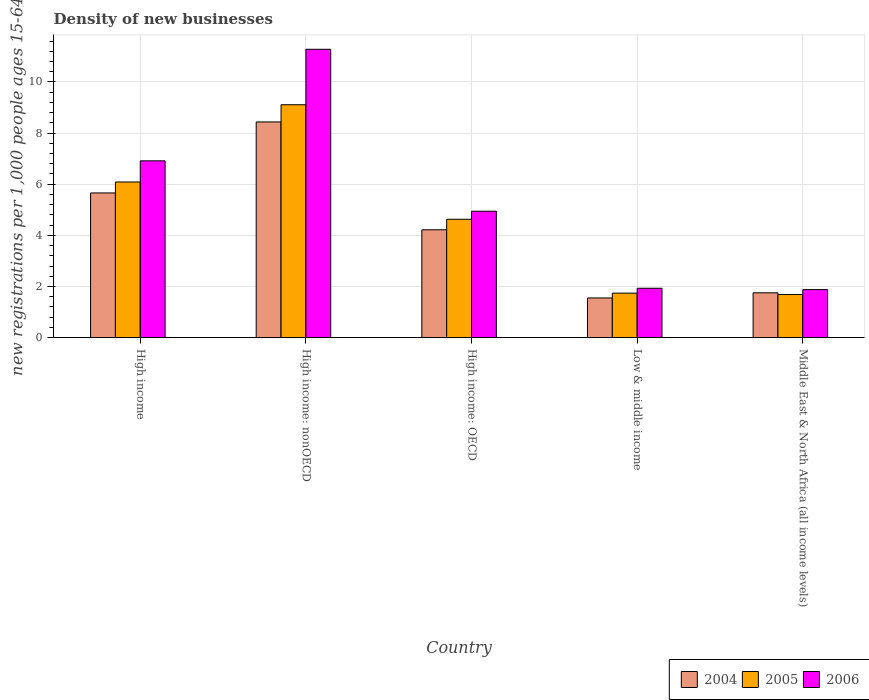How many different coloured bars are there?
Give a very brief answer. 3. Are the number of bars per tick equal to the number of legend labels?
Keep it short and to the point. Yes. What is the label of the 4th group of bars from the left?
Your answer should be very brief. Low & middle income. In how many cases, is the number of bars for a given country not equal to the number of legend labels?
Make the answer very short. 0. What is the number of new registrations in 2005 in High income?
Provide a short and direct response. 6.09. Across all countries, what is the maximum number of new registrations in 2006?
Give a very brief answer. 11.28. Across all countries, what is the minimum number of new registrations in 2005?
Your answer should be compact. 1.69. In which country was the number of new registrations in 2004 maximum?
Offer a very short reply. High income: nonOECD. In which country was the number of new registrations in 2005 minimum?
Give a very brief answer. Middle East & North Africa (all income levels). What is the total number of new registrations in 2006 in the graph?
Provide a short and direct response. 26.95. What is the difference between the number of new registrations in 2006 in High income and that in Middle East & North Africa (all income levels)?
Provide a succinct answer. 5.03. What is the difference between the number of new registrations in 2006 in High income and the number of new registrations in 2004 in High income: OECD?
Provide a succinct answer. 2.7. What is the average number of new registrations in 2004 per country?
Ensure brevity in your answer.  4.32. What is the difference between the number of new registrations of/in 2005 and number of new registrations of/in 2006 in Low & middle income?
Your answer should be compact. -0.19. In how many countries, is the number of new registrations in 2005 greater than 6.8?
Ensure brevity in your answer.  1. What is the ratio of the number of new registrations in 2005 in High income: nonOECD to that in Low & middle income?
Make the answer very short. 5.23. What is the difference between the highest and the second highest number of new registrations in 2004?
Keep it short and to the point. 4.22. What is the difference between the highest and the lowest number of new registrations in 2004?
Give a very brief answer. 6.88. In how many countries, is the number of new registrations in 2006 greater than the average number of new registrations in 2006 taken over all countries?
Provide a short and direct response. 2. Is the sum of the number of new registrations in 2006 in High income and High income: nonOECD greater than the maximum number of new registrations in 2005 across all countries?
Offer a terse response. Yes. What does the 1st bar from the left in High income: OECD represents?
Provide a succinct answer. 2004. How many bars are there?
Keep it short and to the point. 15. How many countries are there in the graph?
Ensure brevity in your answer.  5. What is the difference between two consecutive major ticks on the Y-axis?
Give a very brief answer. 2. Does the graph contain grids?
Offer a terse response. Yes. Where does the legend appear in the graph?
Provide a succinct answer. Bottom right. What is the title of the graph?
Your answer should be very brief. Density of new businesses. What is the label or title of the Y-axis?
Ensure brevity in your answer.  New registrations per 1,0 people ages 15-64. What is the new registrations per 1,000 people ages 15-64 in 2004 in High income?
Make the answer very short. 5.66. What is the new registrations per 1,000 people ages 15-64 of 2005 in High income?
Your answer should be very brief. 6.09. What is the new registrations per 1,000 people ages 15-64 of 2006 in High income?
Offer a terse response. 6.91. What is the new registrations per 1,000 people ages 15-64 of 2004 in High income: nonOECD?
Make the answer very short. 8.44. What is the new registrations per 1,000 people ages 15-64 of 2005 in High income: nonOECD?
Provide a short and direct response. 9.11. What is the new registrations per 1,000 people ages 15-64 of 2006 in High income: nonOECD?
Your response must be concise. 11.28. What is the new registrations per 1,000 people ages 15-64 in 2004 in High income: OECD?
Offer a very short reply. 4.22. What is the new registrations per 1,000 people ages 15-64 in 2005 in High income: OECD?
Offer a very short reply. 4.63. What is the new registrations per 1,000 people ages 15-64 in 2006 in High income: OECD?
Give a very brief answer. 4.94. What is the new registrations per 1,000 people ages 15-64 of 2004 in Low & middle income?
Provide a succinct answer. 1.55. What is the new registrations per 1,000 people ages 15-64 in 2005 in Low & middle income?
Offer a very short reply. 1.74. What is the new registrations per 1,000 people ages 15-64 of 2006 in Low & middle income?
Make the answer very short. 1.93. What is the new registrations per 1,000 people ages 15-64 of 2004 in Middle East & North Africa (all income levels)?
Give a very brief answer. 1.75. What is the new registrations per 1,000 people ages 15-64 of 2005 in Middle East & North Africa (all income levels)?
Provide a succinct answer. 1.69. What is the new registrations per 1,000 people ages 15-64 in 2006 in Middle East & North Africa (all income levels)?
Your answer should be very brief. 1.88. Across all countries, what is the maximum new registrations per 1,000 people ages 15-64 in 2004?
Provide a short and direct response. 8.44. Across all countries, what is the maximum new registrations per 1,000 people ages 15-64 in 2005?
Offer a very short reply. 9.11. Across all countries, what is the maximum new registrations per 1,000 people ages 15-64 in 2006?
Provide a succinct answer. 11.28. Across all countries, what is the minimum new registrations per 1,000 people ages 15-64 of 2004?
Provide a short and direct response. 1.55. Across all countries, what is the minimum new registrations per 1,000 people ages 15-64 in 2005?
Keep it short and to the point. 1.69. Across all countries, what is the minimum new registrations per 1,000 people ages 15-64 in 2006?
Offer a terse response. 1.88. What is the total new registrations per 1,000 people ages 15-64 of 2004 in the graph?
Provide a short and direct response. 21.62. What is the total new registrations per 1,000 people ages 15-64 of 2005 in the graph?
Your answer should be compact. 23.25. What is the total new registrations per 1,000 people ages 15-64 in 2006 in the graph?
Provide a succinct answer. 26.95. What is the difference between the new registrations per 1,000 people ages 15-64 of 2004 in High income and that in High income: nonOECD?
Provide a short and direct response. -2.78. What is the difference between the new registrations per 1,000 people ages 15-64 in 2005 in High income and that in High income: nonOECD?
Your answer should be very brief. -3.02. What is the difference between the new registrations per 1,000 people ages 15-64 of 2006 in High income and that in High income: nonOECD?
Provide a short and direct response. -4.36. What is the difference between the new registrations per 1,000 people ages 15-64 of 2004 in High income and that in High income: OECD?
Your response must be concise. 1.44. What is the difference between the new registrations per 1,000 people ages 15-64 in 2005 in High income and that in High income: OECD?
Your answer should be very brief. 1.46. What is the difference between the new registrations per 1,000 people ages 15-64 in 2006 in High income and that in High income: OECD?
Provide a succinct answer. 1.97. What is the difference between the new registrations per 1,000 people ages 15-64 of 2004 in High income and that in Low & middle income?
Provide a short and direct response. 4.11. What is the difference between the new registrations per 1,000 people ages 15-64 of 2005 in High income and that in Low & middle income?
Offer a terse response. 4.35. What is the difference between the new registrations per 1,000 people ages 15-64 of 2006 in High income and that in Low & middle income?
Keep it short and to the point. 4.98. What is the difference between the new registrations per 1,000 people ages 15-64 of 2004 in High income and that in Middle East & North Africa (all income levels)?
Offer a terse response. 3.91. What is the difference between the new registrations per 1,000 people ages 15-64 in 2005 in High income and that in Middle East & North Africa (all income levels)?
Ensure brevity in your answer.  4.4. What is the difference between the new registrations per 1,000 people ages 15-64 of 2006 in High income and that in Middle East & North Africa (all income levels)?
Make the answer very short. 5.04. What is the difference between the new registrations per 1,000 people ages 15-64 in 2004 in High income: nonOECD and that in High income: OECD?
Your answer should be very brief. 4.22. What is the difference between the new registrations per 1,000 people ages 15-64 in 2005 in High income: nonOECD and that in High income: OECD?
Give a very brief answer. 4.48. What is the difference between the new registrations per 1,000 people ages 15-64 in 2006 in High income: nonOECD and that in High income: OECD?
Provide a short and direct response. 6.33. What is the difference between the new registrations per 1,000 people ages 15-64 of 2004 in High income: nonOECD and that in Low & middle income?
Your answer should be very brief. 6.88. What is the difference between the new registrations per 1,000 people ages 15-64 in 2005 in High income: nonOECD and that in Low & middle income?
Ensure brevity in your answer.  7.37. What is the difference between the new registrations per 1,000 people ages 15-64 of 2006 in High income: nonOECD and that in Low & middle income?
Your response must be concise. 9.34. What is the difference between the new registrations per 1,000 people ages 15-64 in 2004 in High income: nonOECD and that in Middle East & North Africa (all income levels)?
Provide a short and direct response. 6.68. What is the difference between the new registrations per 1,000 people ages 15-64 in 2005 in High income: nonOECD and that in Middle East & North Africa (all income levels)?
Provide a short and direct response. 7.42. What is the difference between the new registrations per 1,000 people ages 15-64 in 2006 in High income: nonOECD and that in Middle East & North Africa (all income levels)?
Make the answer very short. 9.4. What is the difference between the new registrations per 1,000 people ages 15-64 of 2004 in High income: OECD and that in Low & middle income?
Provide a succinct answer. 2.67. What is the difference between the new registrations per 1,000 people ages 15-64 of 2005 in High income: OECD and that in Low & middle income?
Ensure brevity in your answer.  2.89. What is the difference between the new registrations per 1,000 people ages 15-64 in 2006 in High income: OECD and that in Low & middle income?
Keep it short and to the point. 3.01. What is the difference between the new registrations per 1,000 people ages 15-64 in 2004 in High income: OECD and that in Middle East & North Africa (all income levels)?
Keep it short and to the point. 2.47. What is the difference between the new registrations per 1,000 people ages 15-64 of 2005 in High income: OECD and that in Middle East & North Africa (all income levels)?
Give a very brief answer. 2.94. What is the difference between the new registrations per 1,000 people ages 15-64 in 2006 in High income: OECD and that in Middle East & North Africa (all income levels)?
Offer a very short reply. 3.07. What is the difference between the new registrations per 1,000 people ages 15-64 of 2004 in Low & middle income and that in Middle East & North Africa (all income levels)?
Provide a short and direct response. -0.2. What is the difference between the new registrations per 1,000 people ages 15-64 of 2005 in Low & middle income and that in Middle East & North Africa (all income levels)?
Provide a short and direct response. 0.05. What is the difference between the new registrations per 1,000 people ages 15-64 in 2006 in Low & middle income and that in Middle East & North Africa (all income levels)?
Give a very brief answer. 0.05. What is the difference between the new registrations per 1,000 people ages 15-64 of 2004 in High income and the new registrations per 1,000 people ages 15-64 of 2005 in High income: nonOECD?
Your answer should be very brief. -3.45. What is the difference between the new registrations per 1,000 people ages 15-64 of 2004 in High income and the new registrations per 1,000 people ages 15-64 of 2006 in High income: nonOECD?
Provide a short and direct response. -5.62. What is the difference between the new registrations per 1,000 people ages 15-64 in 2005 in High income and the new registrations per 1,000 people ages 15-64 in 2006 in High income: nonOECD?
Provide a succinct answer. -5.19. What is the difference between the new registrations per 1,000 people ages 15-64 in 2004 in High income and the new registrations per 1,000 people ages 15-64 in 2005 in High income: OECD?
Your answer should be very brief. 1.03. What is the difference between the new registrations per 1,000 people ages 15-64 of 2004 in High income and the new registrations per 1,000 people ages 15-64 of 2006 in High income: OECD?
Keep it short and to the point. 0.71. What is the difference between the new registrations per 1,000 people ages 15-64 of 2005 in High income and the new registrations per 1,000 people ages 15-64 of 2006 in High income: OECD?
Keep it short and to the point. 1.14. What is the difference between the new registrations per 1,000 people ages 15-64 in 2004 in High income and the new registrations per 1,000 people ages 15-64 in 2005 in Low & middle income?
Your answer should be compact. 3.92. What is the difference between the new registrations per 1,000 people ages 15-64 of 2004 in High income and the new registrations per 1,000 people ages 15-64 of 2006 in Low & middle income?
Give a very brief answer. 3.73. What is the difference between the new registrations per 1,000 people ages 15-64 in 2005 in High income and the new registrations per 1,000 people ages 15-64 in 2006 in Low & middle income?
Make the answer very short. 4.16. What is the difference between the new registrations per 1,000 people ages 15-64 in 2004 in High income and the new registrations per 1,000 people ages 15-64 in 2005 in Middle East & North Africa (all income levels)?
Make the answer very short. 3.97. What is the difference between the new registrations per 1,000 people ages 15-64 in 2004 in High income and the new registrations per 1,000 people ages 15-64 in 2006 in Middle East & North Africa (all income levels)?
Offer a terse response. 3.78. What is the difference between the new registrations per 1,000 people ages 15-64 in 2005 in High income and the new registrations per 1,000 people ages 15-64 in 2006 in Middle East & North Africa (all income levels)?
Your answer should be very brief. 4.21. What is the difference between the new registrations per 1,000 people ages 15-64 in 2004 in High income: nonOECD and the new registrations per 1,000 people ages 15-64 in 2005 in High income: OECD?
Your answer should be very brief. 3.81. What is the difference between the new registrations per 1,000 people ages 15-64 in 2004 in High income: nonOECD and the new registrations per 1,000 people ages 15-64 in 2006 in High income: OECD?
Keep it short and to the point. 3.49. What is the difference between the new registrations per 1,000 people ages 15-64 of 2005 in High income: nonOECD and the new registrations per 1,000 people ages 15-64 of 2006 in High income: OECD?
Offer a very short reply. 4.16. What is the difference between the new registrations per 1,000 people ages 15-64 of 2004 in High income: nonOECD and the new registrations per 1,000 people ages 15-64 of 2005 in Low & middle income?
Your answer should be compact. 6.69. What is the difference between the new registrations per 1,000 people ages 15-64 of 2004 in High income: nonOECD and the new registrations per 1,000 people ages 15-64 of 2006 in Low & middle income?
Offer a terse response. 6.5. What is the difference between the new registrations per 1,000 people ages 15-64 in 2005 in High income: nonOECD and the new registrations per 1,000 people ages 15-64 in 2006 in Low & middle income?
Keep it short and to the point. 7.18. What is the difference between the new registrations per 1,000 people ages 15-64 of 2004 in High income: nonOECD and the new registrations per 1,000 people ages 15-64 of 2005 in Middle East & North Africa (all income levels)?
Provide a short and direct response. 6.75. What is the difference between the new registrations per 1,000 people ages 15-64 in 2004 in High income: nonOECD and the new registrations per 1,000 people ages 15-64 in 2006 in Middle East & North Africa (all income levels)?
Your answer should be very brief. 6.56. What is the difference between the new registrations per 1,000 people ages 15-64 of 2005 in High income: nonOECD and the new registrations per 1,000 people ages 15-64 of 2006 in Middle East & North Africa (all income levels)?
Ensure brevity in your answer.  7.23. What is the difference between the new registrations per 1,000 people ages 15-64 of 2004 in High income: OECD and the new registrations per 1,000 people ages 15-64 of 2005 in Low & middle income?
Your answer should be very brief. 2.48. What is the difference between the new registrations per 1,000 people ages 15-64 of 2004 in High income: OECD and the new registrations per 1,000 people ages 15-64 of 2006 in Low & middle income?
Make the answer very short. 2.29. What is the difference between the new registrations per 1,000 people ages 15-64 of 2005 in High income: OECD and the new registrations per 1,000 people ages 15-64 of 2006 in Low & middle income?
Make the answer very short. 2.7. What is the difference between the new registrations per 1,000 people ages 15-64 in 2004 in High income: OECD and the new registrations per 1,000 people ages 15-64 in 2005 in Middle East & North Africa (all income levels)?
Keep it short and to the point. 2.53. What is the difference between the new registrations per 1,000 people ages 15-64 of 2004 in High income: OECD and the new registrations per 1,000 people ages 15-64 of 2006 in Middle East & North Africa (all income levels)?
Ensure brevity in your answer.  2.34. What is the difference between the new registrations per 1,000 people ages 15-64 of 2005 in High income: OECD and the new registrations per 1,000 people ages 15-64 of 2006 in Middle East & North Africa (all income levels)?
Provide a short and direct response. 2.75. What is the difference between the new registrations per 1,000 people ages 15-64 of 2004 in Low & middle income and the new registrations per 1,000 people ages 15-64 of 2005 in Middle East & North Africa (all income levels)?
Your response must be concise. -0.13. What is the difference between the new registrations per 1,000 people ages 15-64 in 2004 in Low & middle income and the new registrations per 1,000 people ages 15-64 in 2006 in Middle East & North Africa (all income levels)?
Your answer should be compact. -0.33. What is the difference between the new registrations per 1,000 people ages 15-64 of 2005 in Low & middle income and the new registrations per 1,000 people ages 15-64 of 2006 in Middle East & North Africa (all income levels)?
Your response must be concise. -0.14. What is the average new registrations per 1,000 people ages 15-64 in 2004 per country?
Give a very brief answer. 4.32. What is the average new registrations per 1,000 people ages 15-64 of 2005 per country?
Ensure brevity in your answer.  4.65. What is the average new registrations per 1,000 people ages 15-64 in 2006 per country?
Give a very brief answer. 5.39. What is the difference between the new registrations per 1,000 people ages 15-64 of 2004 and new registrations per 1,000 people ages 15-64 of 2005 in High income?
Provide a short and direct response. -0.43. What is the difference between the new registrations per 1,000 people ages 15-64 of 2004 and new registrations per 1,000 people ages 15-64 of 2006 in High income?
Provide a succinct answer. -1.26. What is the difference between the new registrations per 1,000 people ages 15-64 in 2005 and new registrations per 1,000 people ages 15-64 in 2006 in High income?
Give a very brief answer. -0.83. What is the difference between the new registrations per 1,000 people ages 15-64 of 2004 and new registrations per 1,000 people ages 15-64 of 2005 in High income: nonOECD?
Provide a short and direct response. -0.67. What is the difference between the new registrations per 1,000 people ages 15-64 of 2004 and new registrations per 1,000 people ages 15-64 of 2006 in High income: nonOECD?
Your answer should be compact. -2.84. What is the difference between the new registrations per 1,000 people ages 15-64 in 2005 and new registrations per 1,000 people ages 15-64 in 2006 in High income: nonOECD?
Provide a short and direct response. -2.17. What is the difference between the new registrations per 1,000 people ages 15-64 of 2004 and new registrations per 1,000 people ages 15-64 of 2005 in High income: OECD?
Your answer should be very brief. -0.41. What is the difference between the new registrations per 1,000 people ages 15-64 in 2004 and new registrations per 1,000 people ages 15-64 in 2006 in High income: OECD?
Ensure brevity in your answer.  -0.73. What is the difference between the new registrations per 1,000 people ages 15-64 in 2005 and new registrations per 1,000 people ages 15-64 in 2006 in High income: OECD?
Your answer should be compact. -0.32. What is the difference between the new registrations per 1,000 people ages 15-64 of 2004 and new registrations per 1,000 people ages 15-64 of 2005 in Low & middle income?
Give a very brief answer. -0.19. What is the difference between the new registrations per 1,000 people ages 15-64 in 2004 and new registrations per 1,000 people ages 15-64 in 2006 in Low & middle income?
Offer a terse response. -0.38. What is the difference between the new registrations per 1,000 people ages 15-64 of 2005 and new registrations per 1,000 people ages 15-64 of 2006 in Low & middle income?
Give a very brief answer. -0.19. What is the difference between the new registrations per 1,000 people ages 15-64 of 2004 and new registrations per 1,000 people ages 15-64 of 2005 in Middle East & North Africa (all income levels)?
Give a very brief answer. 0.07. What is the difference between the new registrations per 1,000 people ages 15-64 in 2004 and new registrations per 1,000 people ages 15-64 in 2006 in Middle East & North Africa (all income levels)?
Provide a succinct answer. -0.13. What is the difference between the new registrations per 1,000 people ages 15-64 in 2005 and new registrations per 1,000 people ages 15-64 in 2006 in Middle East & North Africa (all income levels)?
Provide a succinct answer. -0.19. What is the ratio of the new registrations per 1,000 people ages 15-64 of 2004 in High income to that in High income: nonOECD?
Ensure brevity in your answer.  0.67. What is the ratio of the new registrations per 1,000 people ages 15-64 in 2005 in High income to that in High income: nonOECD?
Your response must be concise. 0.67. What is the ratio of the new registrations per 1,000 people ages 15-64 in 2006 in High income to that in High income: nonOECD?
Give a very brief answer. 0.61. What is the ratio of the new registrations per 1,000 people ages 15-64 of 2004 in High income to that in High income: OECD?
Ensure brevity in your answer.  1.34. What is the ratio of the new registrations per 1,000 people ages 15-64 in 2005 in High income to that in High income: OECD?
Offer a terse response. 1.31. What is the ratio of the new registrations per 1,000 people ages 15-64 of 2006 in High income to that in High income: OECD?
Ensure brevity in your answer.  1.4. What is the ratio of the new registrations per 1,000 people ages 15-64 of 2004 in High income to that in Low & middle income?
Your answer should be very brief. 3.64. What is the ratio of the new registrations per 1,000 people ages 15-64 of 2005 in High income to that in Low & middle income?
Offer a terse response. 3.5. What is the ratio of the new registrations per 1,000 people ages 15-64 in 2006 in High income to that in Low & middle income?
Provide a succinct answer. 3.58. What is the ratio of the new registrations per 1,000 people ages 15-64 of 2004 in High income to that in Middle East & North Africa (all income levels)?
Make the answer very short. 3.23. What is the ratio of the new registrations per 1,000 people ages 15-64 of 2005 in High income to that in Middle East & North Africa (all income levels)?
Provide a succinct answer. 3.61. What is the ratio of the new registrations per 1,000 people ages 15-64 in 2006 in High income to that in Middle East & North Africa (all income levels)?
Make the answer very short. 3.68. What is the ratio of the new registrations per 1,000 people ages 15-64 in 2004 in High income: nonOECD to that in High income: OECD?
Ensure brevity in your answer.  2. What is the ratio of the new registrations per 1,000 people ages 15-64 in 2005 in High income: nonOECD to that in High income: OECD?
Provide a short and direct response. 1.97. What is the ratio of the new registrations per 1,000 people ages 15-64 in 2006 in High income: nonOECD to that in High income: OECD?
Keep it short and to the point. 2.28. What is the ratio of the new registrations per 1,000 people ages 15-64 of 2004 in High income: nonOECD to that in Low & middle income?
Ensure brevity in your answer.  5.43. What is the ratio of the new registrations per 1,000 people ages 15-64 of 2005 in High income: nonOECD to that in Low & middle income?
Ensure brevity in your answer.  5.23. What is the ratio of the new registrations per 1,000 people ages 15-64 of 2006 in High income: nonOECD to that in Low & middle income?
Make the answer very short. 5.84. What is the ratio of the new registrations per 1,000 people ages 15-64 in 2004 in High income: nonOECD to that in Middle East & North Africa (all income levels)?
Your answer should be very brief. 4.81. What is the ratio of the new registrations per 1,000 people ages 15-64 in 2005 in High income: nonOECD to that in Middle East & North Africa (all income levels)?
Keep it short and to the point. 5.4. What is the ratio of the new registrations per 1,000 people ages 15-64 in 2006 in High income: nonOECD to that in Middle East & North Africa (all income levels)?
Your answer should be compact. 6. What is the ratio of the new registrations per 1,000 people ages 15-64 in 2004 in High income: OECD to that in Low & middle income?
Offer a very short reply. 2.72. What is the ratio of the new registrations per 1,000 people ages 15-64 of 2005 in High income: OECD to that in Low & middle income?
Your response must be concise. 2.66. What is the ratio of the new registrations per 1,000 people ages 15-64 of 2006 in High income: OECD to that in Low & middle income?
Your answer should be very brief. 2.56. What is the ratio of the new registrations per 1,000 people ages 15-64 in 2004 in High income: OECD to that in Middle East & North Africa (all income levels)?
Give a very brief answer. 2.41. What is the ratio of the new registrations per 1,000 people ages 15-64 in 2005 in High income: OECD to that in Middle East & North Africa (all income levels)?
Your response must be concise. 2.74. What is the ratio of the new registrations per 1,000 people ages 15-64 in 2006 in High income: OECD to that in Middle East & North Africa (all income levels)?
Provide a succinct answer. 2.63. What is the ratio of the new registrations per 1,000 people ages 15-64 of 2004 in Low & middle income to that in Middle East & North Africa (all income levels)?
Offer a very short reply. 0.89. What is the ratio of the new registrations per 1,000 people ages 15-64 of 2005 in Low & middle income to that in Middle East & North Africa (all income levels)?
Your response must be concise. 1.03. What is the ratio of the new registrations per 1,000 people ages 15-64 of 2006 in Low & middle income to that in Middle East & North Africa (all income levels)?
Your answer should be compact. 1.03. What is the difference between the highest and the second highest new registrations per 1,000 people ages 15-64 of 2004?
Make the answer very short. 2.78. What is the difference between the highest and the second highest new registrations per 1,000 people ages 15-64 in 2005?
Offer a terse response. 3.02. What is the difference between the highest and the second highest new registrations per 1,000 people ages 15-64 in 2006?
Offer a very short reply. 4.36. What is the difference between the highest and the lowest new registrations per 1,000 people ages 15-64 in 2004?
Ensure brevity in your answer.  6.88. What is the difference between the highest and the lowest new registrations per 1,000 people ages 15-64 of 2005?
Your answer should be compact. 7.42. What is the difference between the highest and the lowest new registrations per 1,000 people ages 15-64 of 2006?
Keep it short and to the point. 9.4. 